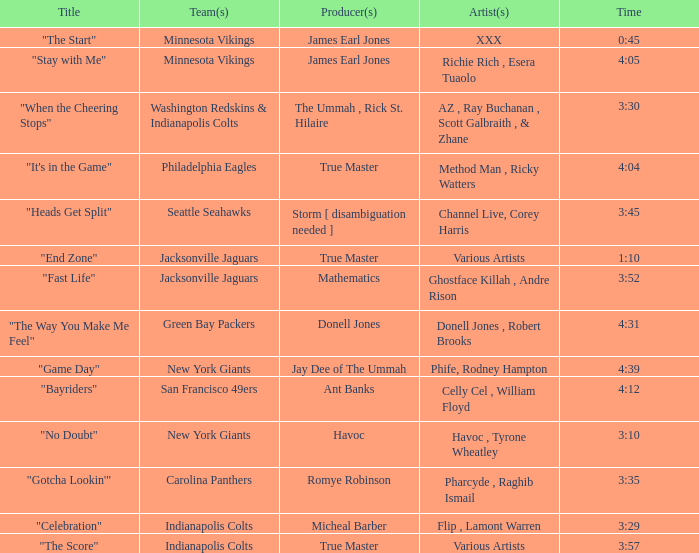What teams used a track 3:29 long? Indianapolis Colts. 